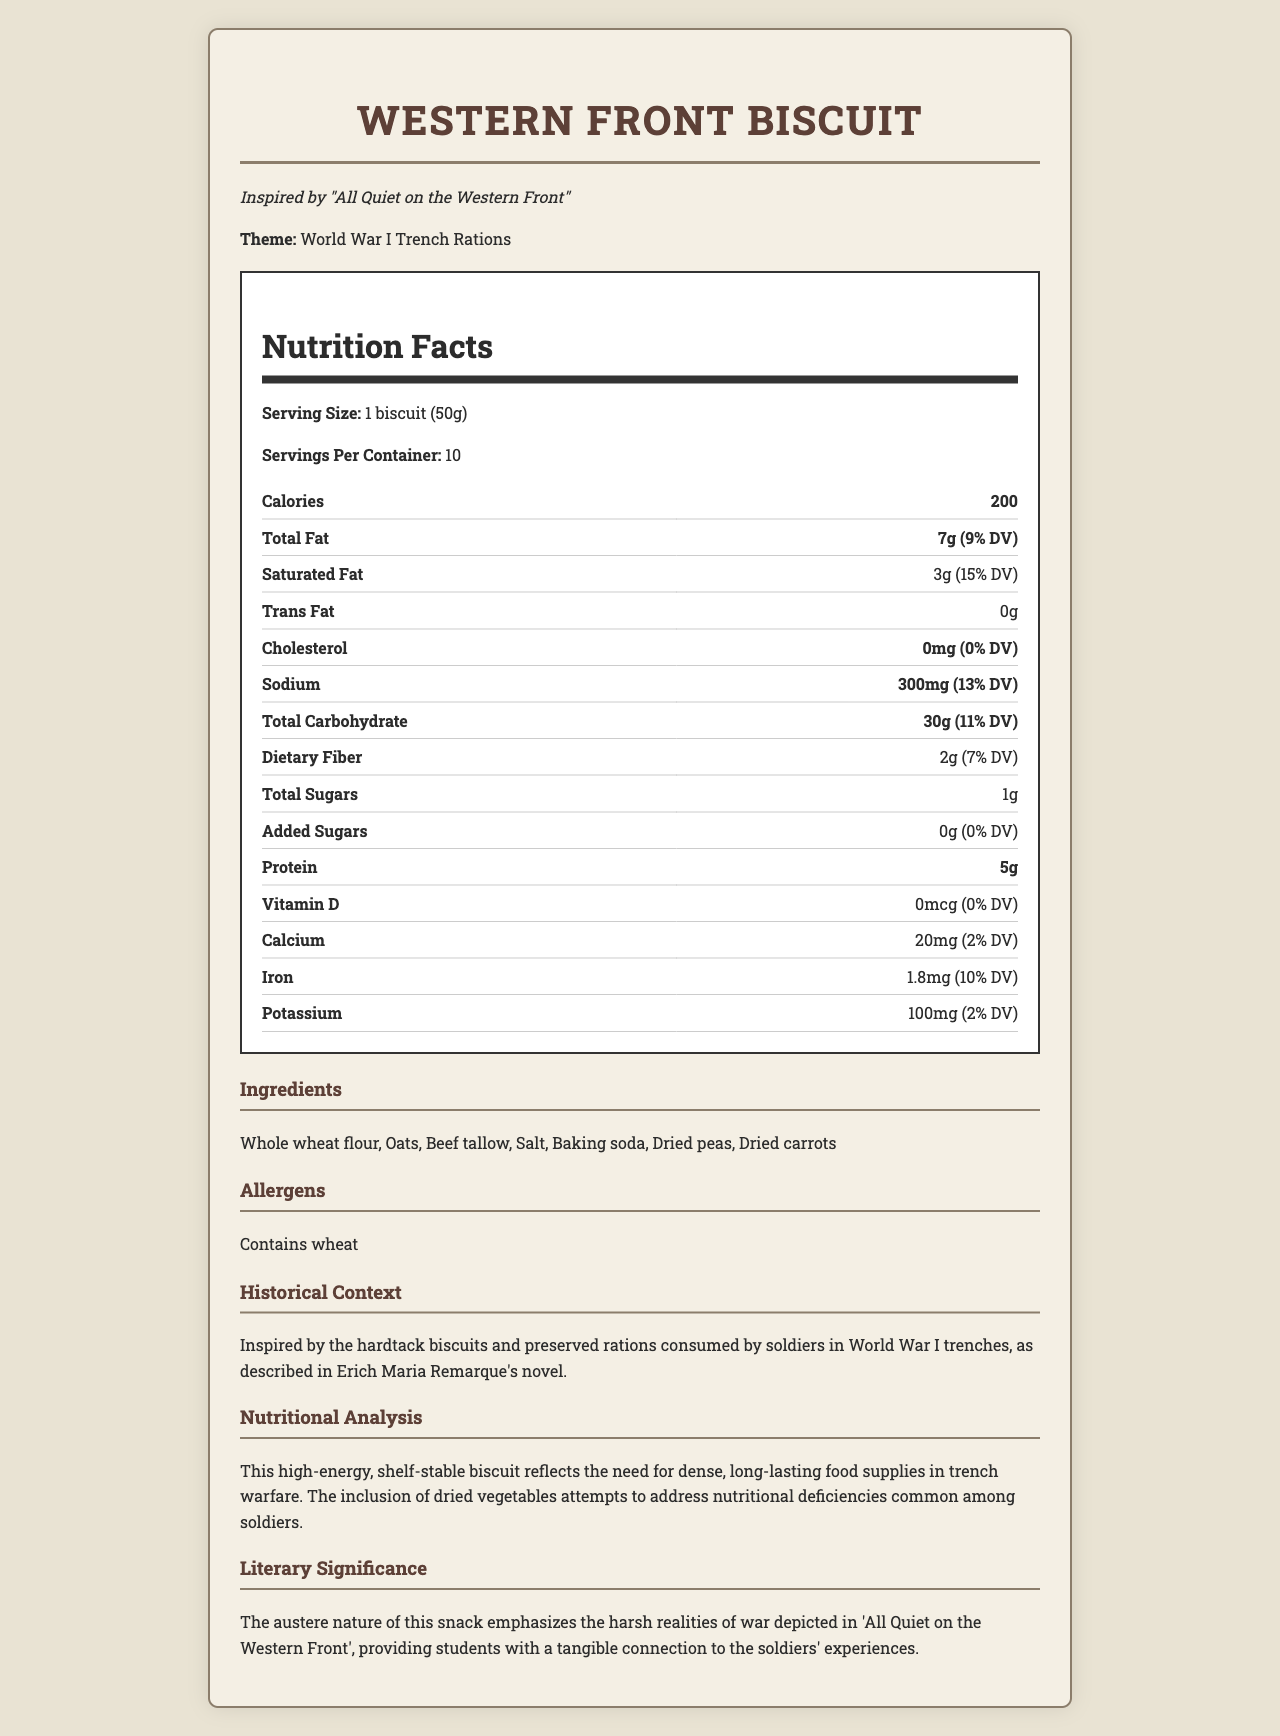what is the serving size of the Western Front Biscuit? The serving size is mentioned under the "Nutrition Facts" section as "Serving Size: 1 biscuit (50g)".
Answer: 1 biscuit (50g) how many calories are in one serving of the Western Front Biscuit? The calorie amount is stated in the "Nutrition Facts" section under "Calories" as 200.
Answer: 200 what ingredient in the Western Front Biscuit might cause allergies? The allergens section explicitly states "Contains wheat".
Answer: Wheat how many grams of protein are in one Western Front Biscuit? The amount of protein is listed in the "Nutrition Facts" table under "Protein" as 5g.
Answer: 5g what is the main literary significance of the Western Front Biscuit? This is detailed in the "Literary Significance" section near the end of the document.
Answer: The austere nature of this snack emphasizes the harsh realities of war depicted in 'All Quiet on the Western Front', providing students with a tangible connection to the soldiers' experiences. how much iron is in one serving of Western Front Biscuit? The amount of iron is shown in the "Nutrition Facts" section under "Iron" as 1.8mg (10% DV).
Answer: 1.8mg (10% DV) how is the Western Front Biscuit related to historical trench rations? The "Historical Context" section explains this relationship directly.
Answer: Inspired by the hardtack biscuits and preserved rations consumed by soldiers in World War I trenches, as described in Erich Maria Remarque's novel. what percentage of the daily value of potassium does the Western Front Biscuit provide? This information is found in the "Nutrition Facts" table under "Potassium" as 2% DV.
Answer: 2% which of the following is a primary ingredient in the Western Front Biscuit?
A. Sugar  
B. Whole wheat flour  
C. Raisins  
D. Corn syrup The ingredients list includes "Whole wheat flour" as one of the primary ingredients.
Answer: B how many servings are in one container of the Western Front Biscuit?  
1. 5  
2. 10  
3. 15  
4. 20 The "Nutrition Facts" section mentions "Servings Per Container" as 10.
Answer: 2 does the Western Front Biscuit contain any added sugars? The "Nutrition Facts" section under "Added Sugars" lists 0g.
Answer: No summarize the main idea of the Western Front Biscuit document. The document provides nutritional facts, ingredients, allergens, historical context, and literary significance of the Western Front Biscuit, connecting it to the soldiers' diet in World War I.
Answer: The Western Front Biscuit is a high-energy, shelf-stable snack inspired by World War I trench rations, providing a tangible connection to the soldiers' harsh experiences as described in "All Quiet on the Western Front". It contains essential nutrients with a focus on long-lasting and dense food supplies. what is the history behind the use of baking soda in trench rations? The document does not provide specific information related to the history or use of baking soda in trench rations.
Answer: Cannot be determined 